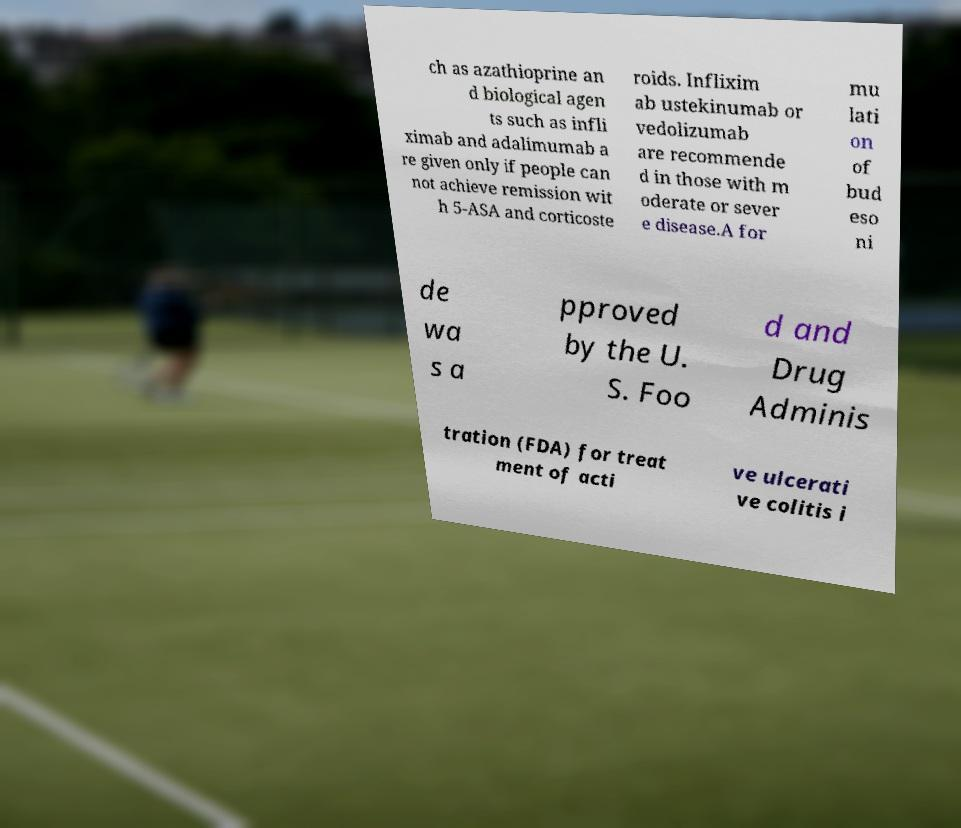What messages or text are displayed in this image? I need them in a readable, typed format. ch as azathioprine an d biological agen ts such as infli ximab and adalimumab a re given only if people can not achieve remission wit h 5-ASA and corticoste roids. Inflixim ab ustekinumab or vedolizumab are recommende d in those with m oderate or sever e disease.A for mu lati on of bud eso ni de wa s a pproved by the U. S. Foo d and Drug Adminis tration (FDA) for treat ment of acti ve ulcerati ve colitis i 